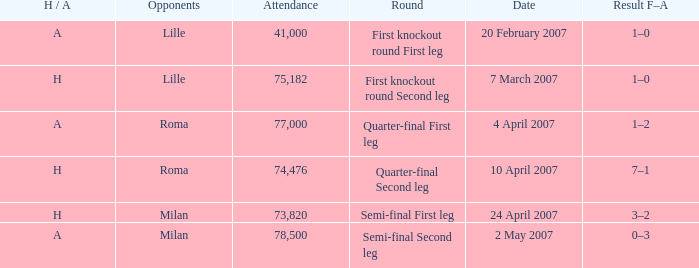Which round has an Opponent of lille, and a H / A of h? First knockout round Second leg. 